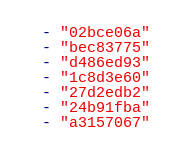<code> <loc_0><loc_0><loc_500><loc_500><_YAML_>  - "02bce06a"
  - "bec83775"
  - "d486ed93"
  - "1c8d3e60"
  - "27d2edb2"
  - "24b91fba"
  - "a3157067"</code> 